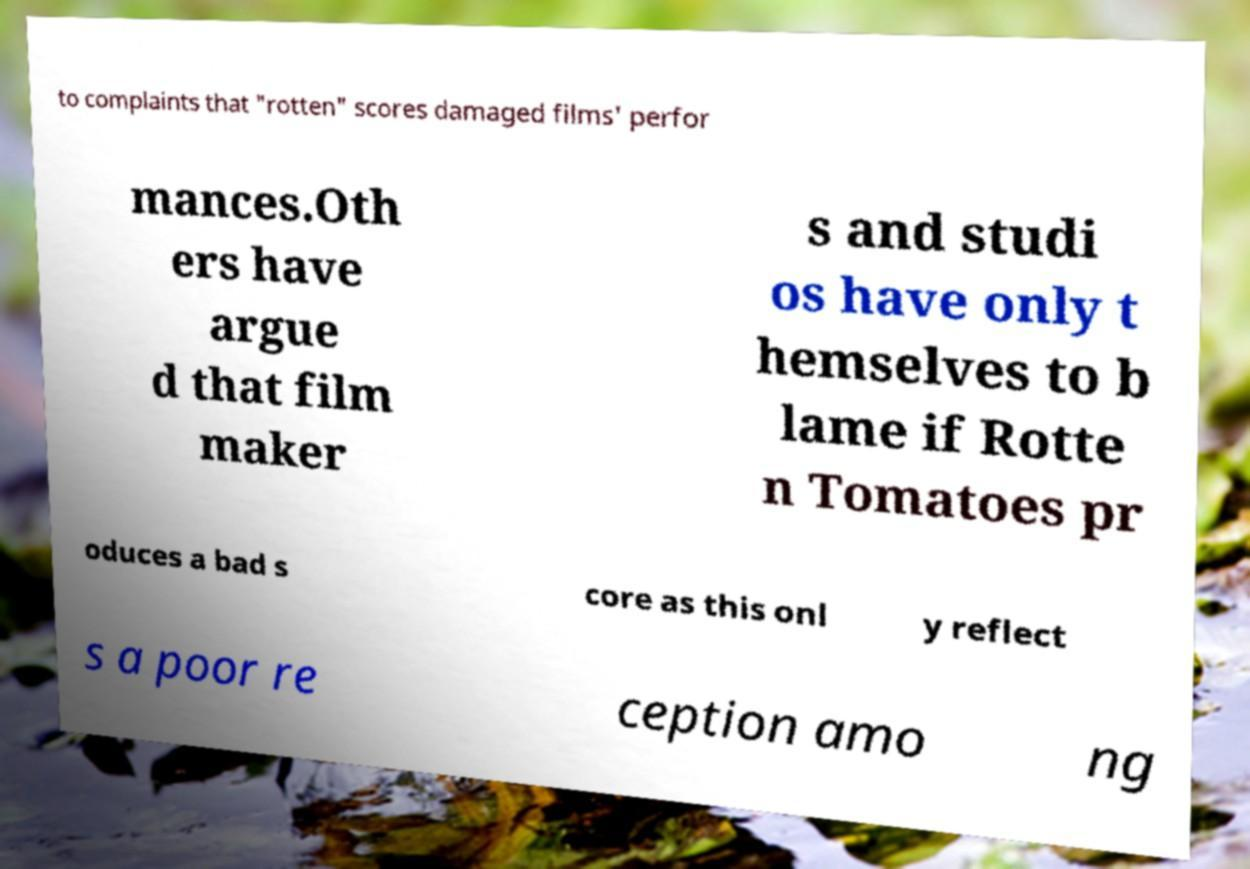Can you accurately transcribe the text from the provided image for me? to complaints that "rotten" scores damaged films' perfor mances.Oth ers have argue d that film maker s and studi os have only t hemselves to b lame if Rotte n Tomatoes pr oduces a bad s core as this onl y reflect s a poor re ception amo ng 